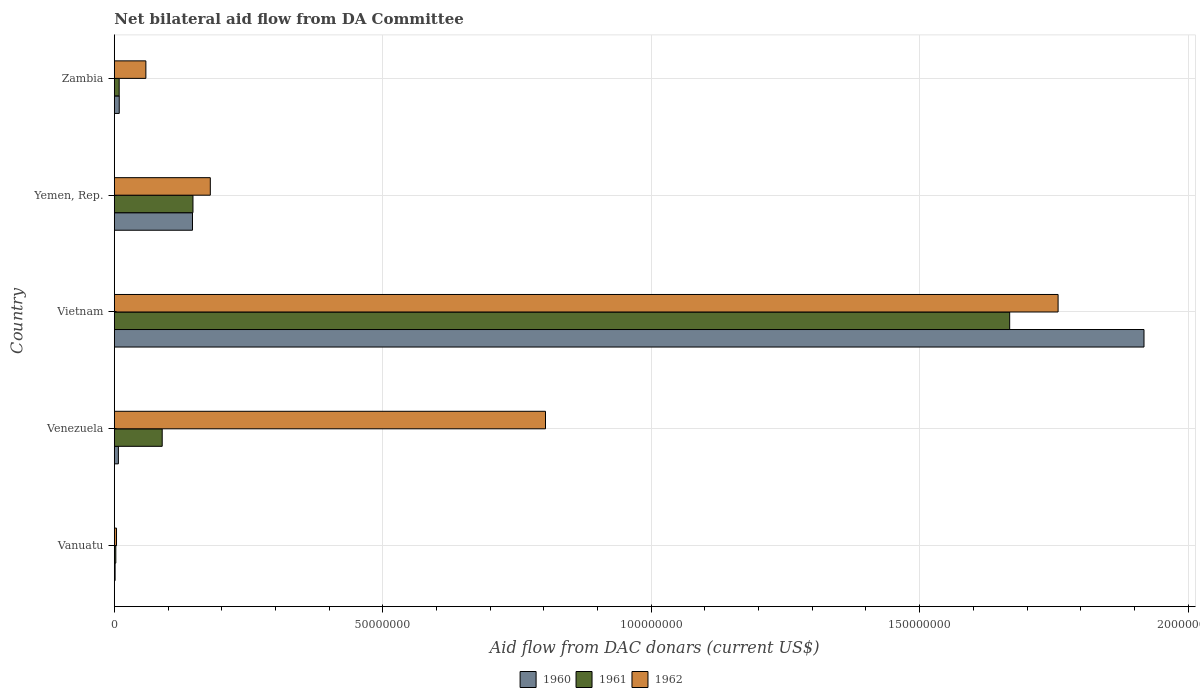How many different coloured bars are there?
Offer a terse response. 3. How many groups of bars are there?
Offer a very short reply. 5. Are the number of bars per tick equal to the number of legend labels?
Your answer should be very brief. Yes. What is the label of the 1st group of bars from the top?
Ensure brevity in your answer.  Zambia. What is the aid flow in in 1960 in Yemen, Rep.?
Your answer should be very brief. 1.46e+07. Across all countries, what is the maximum aid flow in in 1962?
Provide a succinct answer. 1.76e+08. In which country was the aid flow in in 1962 maximum?
Your answer should be very brief. Vietnam. In which country was the aid flow in in 1962 minimum?
Offer a terse response. Vanuatu. What is the total aid flow in in 1961 in the graph?
Offer a very short reply. 1.92e+08. What is the difference between the aid flow in in 1960 in Venezuela and that in Yemen, Rep.?
Provide a short and direct response. -1.38e+07. What is the average aid flow in in 1960 per country?
Ensure brevity in your answer.  4.16e+07. What is the difference between the aid flow in in 1960 and aid flow in in 1961 in Vietnam?
Offer a terse response. 2.50e+07. In how many countries, is the aid flow in in 1961 greater than 40000000 US$?
Your answer should be compact. 1. What is the ratio of the aid flow in in 1961 in Vietnam to that in Zambia?
Your answer should be very brief. 183.25. Is the aid flow in in 1960 in Vanuatu less than that in Zambia?
Your answer should be very brief. Yes. Is the difference between the aid flow in in 1960 in Vietnam and Yemen, Rep. greater than the difference between the aid flow in in 1961 in Vietnam and Yemen, Rep.?
Your answer should be very brief. Yes. What is the difference between the highest and the second highest aid flow in in 1960?
Give a very brief answer. 1.77e+08. What is the difference between the highest and the lowest aid flow in in 1960?
Your answer should be compact. 1.92e+08. Is the sum of the aid flow in in 1961 in Vietnam and Zambia greater than the maximum aid flow in in 1960 across all countries?
Offer a terse response. No. What does the 2nd bar from the bottom in Vanuatu represents?
Your answer should be compact. 1961. How many bars are there?
Give a very brief answer. 15. Are all the bars in the graph horizontal?
Provide a succinct answer. Yes. How many countries are there in the graph?
Your answer should be compact. 5. Are the values on the major ticks of X-axis written in scientific E-notation?
Offer a very short reply. No. Does the graph contain any zero values?
Give a very brief answer. No. Does the graph contain grids?
Keep it short and to the point. Yes. Where does the legend appear in the graph?
Provide a short and direct response. Bottom center. What is the title of the graph?
Make the answer very short. Net bilateral aid flow from DA Committee. Does "2015" appear as one of the legend labels in the graph?
Give a very brief answer. No. What is the label or title of the X-axis?
Provide a succinct answer. Aid flow from DAC donars (current US$). What is the Aid flow from DAC donars (current US$) in 1960 in Vanuatu?
Keep it short and to the point. 1.50e+05. What is the Aid flow from DAC donars (current US$) of 1961 in Vanuatu?
Ensure brevity in your answer.  2.80e+05. What is the Aid flow from DAC donars (current US$) of 1962 in Vanuatu?
Your answer should be very brief. 4.10e+05. What is the Aid flow from DAC donars (current US$) in 1960 in Venezuela?
Your answer should be very brief. 7.60e+05. What is the Aid flow from DAC donars (current US$) in 1961 in Venezuela?
Your response must be concise. 8.92e+06. What is the Aid flow from DAC donars (current US$) of 1962 in Venezuela?
Offer a terse response. 8.03e+07. What is the Aid flow from DAC donars (current US$) in 1960 in Vietnam?
Your answer should be very brief. 1.92e+08. What is the Aid flow from DAC donars (current US$) in 1961 in Vietnam?
Your response must be concise. 1.67e+08. What is the Aid flow from DAC donars (current US$) of 1962 in Vietnam?
Offer a terse response. 1.76e+08. What is the Aid flow from DAC donars (current US$) of 1960 in Yemen, Rep.?
Keep it short and to the point. 1.46e+07. What is the Aid flow from DAC donars (current US$) in 1961 in Yemen, Rep.?
Ensure brevity in your answer.  1.46e+07. What is the Aid flow from DAC donars (current US$) of 1962 in Yemen, Rep.?
Make the answer very short. 1.79e+07. What is the Aid flow from DAC donars (current US$) in 1960 in Zambia?
Offer a very short reply. 9.20e+05. What is the Aid flow from DAC donars (current US$) of 1961 in Zambia?
Give a very brief answer. 9.10e+05. What is the Aid flow from DAC donars (current US$) in 1962 in Zambia?
Offer a very short reply. 5.88e+06. Across all countries, what is the maximum Aid flow from DAC donars (current US$) in 1960?
Give a very brief answer. 1.92e+08. Across all countries, what is the maximum Aid flow from DAC donars (current US$) in 1961?
Your answer should be compact. 1.67e+08. Across all countries, what is the maximum Aid flow from DAC donars (current US$) in 1962?
Keep it short and to the point. 1.76e+08. Across all countries, what is the minimum Aid flow from DAC donars (current US$) in 1961?
Give a very brief answer. 2.80e+05. Across all countries, what is the minimum Aid flow from DAC donars (current US$) in 1962?
Your response must be concise. 4.10e+05. What is the total Aid flow from DAC donars (current US$) of 1960 in the graph?
Your answer should be very brief. 2.08e+08. What is the total Aid flow from DAC donars (current US$) in 1961 in the graph?
Ensure brevity in your answer.  1.92e+08. What is the total Aid flow from DAC donars (current US$) of 1962 in the graph?
Keep it short and to the point. 2.80e+08. What is the difference between the Aid flow from DAC donars (current US$) in 1960 in Vanuatu and that in Venezuela?
Offer a very short reply. -6.10e+05. What is the difference between the Aid flow from DAC donars (current US$) of 1961 in Vanuatu and that in Venezuela?
Your answer should be compact. -8.64e+06. What is the difference between the Aid flow from DAC donars (current US$) of 1962 in Vanuatu and that in Venezuela?
Provide a short and direct response. -7.99e+07. What is the difference between the Aid flow from DAC donars (current US$) in 1960 in Vanuatu and that in Vietnam?
Provide a succinct answer. -1.92e+08. What is the difference between the Aid flow from DAC donars (current US$) of 1961 in Vanuatu and that in Vietnam?
Offer a terse response. -1.66e+08. What is the difference between the Aid flow from DAC donars (current US$) in 1962 in Vanuatu and that in Vietnam?
Provide a succinct answer. -1.75e+08. What is the difference between the Aid flow from DAC donars (current US$) in 1960 in Vanuatu and that in Yemen, Rep.?
Ensure brevity in your answer.  -1.44e+07. What is the difference between the Aid flow from DAC donars (current US$) in 1961 in Vanuatu and that in Yemen, Rep.?
Give a very brief answer. -1.44e+07. What is the difference between the Aid flow from DAC donars (current US$) of 1962 in Vanuatu and that in Yemen, Rep.?
Offer a terse response. -1.75e+07. What is the difference between the Aid flow from DAC donars (current US$) of 1960 in Vanuatu and that in Zambia?
Offer a very short reply. -7.70e+05. What is the difference between the Aid flow from DAC donars (current US$) of 1961 in Vanuatu and that in Zambia?
Make the answer very short. -6.30e+05. What is the difference between the Aid flow from DAC donars (current US$) of 1962 in Vanuatu and that in Zambia?
Provide a succinct answer. -5.47e+06. What is the difference between the Aid flow from DAC donars (current US$) in 1960 in Venezuela and that in Vietnam?
Provide a short and direct response. -1.91e+08. What is the difference between the Aid flow from DAC donars (current US$) of 1961 in Venezuela and that in Vietnam?
Provide a succinct answer. -1.58e+08. What is the difference between the Aid flow from DAC donars (current US$) of 1962 in Venezuela and that in Vietnam?
Give a very brief answer. -9.55e+07. What is the difference between the Aid flow from DAC donars (current US$) of 1960 in Venezuela and that in Yemen, Rep.?
Provide a succinct answer. -1.38e+07. What is the difference between the Aid flow from DAC donars (current US$) of 1961 in Venezuela and that in Yemen, Rep.?
Offer a terse response. -5.73e+06. What is the difference between the Aid flow from DAC donars (current US$) of 1962 in Venezuela and that in Yemen, Rep.?
Provide a short and direct response. 6.24e+07. What is the difference between the Aid flow from DAC donars (current US$) of 1960 in Venezuela and that in Zambia?
Your answer should be very brief. -1.60e+05. What is the difference between the Aid flow from DAC donars (current US$) of 1961 in Venezuela and that in Zambia?
Ensure brevity in your answer.  8.01e+06. What is the difference between the Aid flow from DAC donars (current US$) in 1962 in Venezuela and that in Zambia?
Give a very brief answer. 7.44e+07. What is the difference between the Aid flow from DAC donars (current US$) in 1960 in Vietnam and that in Yemen, Rep.?
Offer a very short reply. 1.77e+08. What is the difference between the Aid flow from DAC donars (current US$) of 1961 in Vietnam and that in Yemen, Rep.?
Your response must be concise. 1.52e+08. What is the difference between the Aid flow from DAC donars (current US$) of 1962 in Vietnam and that in Yemen, Rep.?
Offer a very short reply. 1.58e+08. What is the difference between the Aid flow from DAC donars (current US$) of 1960 in Vietnam and that in Zambia?
Give a very brief answer. 1.91e+08. What is the difference between the Aid flow from DAC donars (current US$) of 1961 in Vietnam and that in Zambia?
Provide a short and direct response. 1.66e+08. What is the difference between the Aid flow from DAC donars (current US$) of 1962 in Vietnam and that in Zambia?
Your answer should be compact. 1.70e+08. What is the difference between the Aid flow from DAC donars (current US$) of 1960 in Yemen, Rep. and that in Zambia?
Ensure brevity in your answer.  1.36e+07. What is the difference between the Aid flow from DAC donars (current US$) in 1961 in Yemen, Rep. and that in Zambia?
Make the answer very short. 1.37e+07. What is the difference between the Aid flow from DAC donars (current US$) of 1962 in Yemen, Rep. and that in Zambia?
Offer a terse response. 1.20e+07. What is the difference between the Aid flow from DAC donars (current US$) in 1960 in Vanuatu and the Aid flow from DAC donars (current US$) in 1961 in Venezuela?
Your response must be concise. -8.77e+06. What is the difference between the Aid flow from DAC donars (current US$) in 1960 in Vanuatu and the Aid flow from DAC donars (current US$) in 1962 in Venezuela?
Provide a short and direct response. -8.02e+07. What is the difference between the Aid flow from DAC donars (current US$) in 1961 in Vanuatu and the Aid flow from DAC donars (current US$) in 1962 in Venezuela?
Offer a very short reply. -8.00e+07. What is the difference between the Aid flow from DAC donars (current US$) of 1960 in Vanuatu and the Aid flow from DAC donars (current US$) of 1961 in Vietnam?
Make the answer very short. -1.67e+08. What is the difference between the Aid flow from DAC donars (current US$) in 1960 in Vanuatu and the Aid flow from DAC donars (current US$) in 1962 in Vietnam?
Offer a terse response. -1.76e+08. What is the difference between the Aid flow from DAC donars (current US$) in 1961 in Vanuatu and the Aid flow from DAC donars (current US$) in 1962 in Vietnam?
Ensure brevity in your answer.  -1.76e+08. What is the difference between the Aid flow from DAC donars (current US$) of 1960 in Vanuatu and the Aid flow from DAC donars (current US$) of 1961 in Yemen, Rep.?
Provide a short and direct response. -1.45e+07. What is the difference between the Aid flow from DAC donars (current US$) of 1960 in Vanuatu and the Aid flow from DAC donars (current US$) of 1962 in Yemen, Rep.?
Offer a very short reply. -1.77e+07. What is the difference between the Aid flow from DAC donars (current US$) in 1961 in Vanuatu and the Aid flow from DAC donars (current US$) in 1962 in Yemen, Rep.?
Ensure brevity in your answer.  -1.76e+07. What is the difference between the Aid flow from DAC donars (current US$) of 1960 in Vanuatu and the Aid flow from DAC donars (current US$) of 1961 in Zambia?
Ensure brevity in your answer.  -7.60e+05. What is the difference between the Aid flow from DAC donars (current US$) of 1960 in Vanuatu and the Aid flow from DAC donars (current US$) of 1962 in Zambia?
Give a very brief answer. -5.73e+06. What is the difference between the Aid flow from DAC donars (current US$) of 1961 in Vanuatu and the Aid flow from DAC donars (current US$) of 1962 in Zambia?
Your answer should be very brief. -5.60e+06. What is the difference between the Aid flow from DAC donars (current US$) of 1960 in Venezuela and the Aid flow from DAC donars (current US$) of 1961 in Vietnam?
Offer a very short reply. -1.66e+08. What is the difference between the Aid flow from DAC donars (current US$) of 1960 in Venezuela and the Aid flow from DAC donars (current US$) of 1962 in Vietnam?
Provide a short and direct response. -1.75e+08. What is the difference between the Aid flow from DAC donars (current US$) in 1961 in Venezuela and the Aid flow from DAC donars (current US$) in 1962 in Vietnam?
Make the answer very short. -1.67e+08. What is the difference between the Aid flow from DAC donars (current US$) in 1960 in Venezuela and the Aid flow from DAC donars (current US$) in 1961 in Yemen, Rep.?
Your answer should be very brief. -1.39e+07. What is the difference between the Aid flow from DAC donars (current US$) in 1960 in Venezuela and the Aid flow from DAC donars (current US$) in 1962 in Yemen, Rep.?
Keep it short and to the point. -1.71e+07. What is the difference between the Aid flow from DAC donars (current US$) in 1961 in Venezuela and the Aid flow from DAC donars (current US$) in 1962 in Yemen, Rep.?
Your answer should be very brief. -8.96e+06. What is the difference between the Aid flow from DAC donars (current US$) in 1960 in Venezuela and the Aid flow from DAC donars (current US$) in 1962 in Zambia?
Your answer should be compact. -5.12e+06. What is the difference between the Aid flow from DAC donars (current US$) in 1961 in Venezuela and the Aid flow from DAC donars (current US$) in 1962 in Zambia?
Offer a very short reply. 3.04e+06. What is the difference between the Aid flow from DAC donars (current US$) of 1960 in Vietnam and the Aid flow from DAC donars (current US$) of 1961 in Yemen, Rep.?
Ensure brevity in your answer.  1.77e+08. What is the difference between the Aid flow from DAC donars (current US$) in 1960 in Vietnam and the Aid flow from DAC donars (current US$) in 1962 in Yemen, Rep.?
Give a very brief answer. 1.74e+08. What is the difference between the Aid flow from DAC donars (current US$) of 1961 in Vietnam and the Aid flow from DAC donars (current US$) of 1962 in Yemen, Rep.?
Your answer should be compact. 1.49e+08. What is the difference between the Aid flow from DAC donars (current US$) of 1960 in Vietnam and the Aid flow from DAC donars (current US$) of 1961 in Zambia?
Give a very brief answer. 1.91e+08. What is the difference between the Aid flow from DAC donars (current US$) of 1960 in Vietnam and the Aid flow from DAC donars (current US$) of 1962 in Zambia?
Make the answer very short. 1.86e+08. What is the difference between the Aid flow from DAC donars (current US$) in 1961 in Vietnam and the Aid flow from DAC donars (current US$) in 1962 in Zambia?
Offer a very short reply. 1.61e+08. What is the difference between the Aid flow from DAC donars (current US$) in 1960 in Yemen, Rep. and the Aid flow from DAC donars (current US$) in 1961 in Zambia?
Your answer should be compact. 1.36e+07. What is the difference between the Aid flow from DAC donars (current US$) in 1960 in Yemen, Rep. and the Aid flow from DAC donars (current US$) in 1962 in Zambia?
Ensure brevity in your answer.  8.68e+06. What is the difference between the Aid flow from DAC donars (current US$) of 1961 in Yemen, Rep. and the Aid flow from DAC donars (current US$) of 1962 in Zambia?
Provide a succinct answer. 8.77e+06. What is the average Aid flow from DAC donars (current US$) of 1960 per country?
Provide a short and direct response. 4.16e+07. What is the average Aid flow from DAC donars (current US$) in 1961 per country?
Give a very brief answer. 3.83e+07. What is the average Aid flow from DAC donars (current US$) of 1962 per country?
Provide a succinct answer. 5.61e+07. What is the difference between the Aid flow from DAC donars (current US$) of 1960 and Aid flow from DAC donars (current US$) of 1962 in Vanuatu?
Provide a short and direct response. -2.60e+05. What is the difference between the Aid flow from DAC donars (current US$) in 1961 and Aid flow from DAC donars (current US$) in 1962 in Vanuatu?
Provide a short and direct response. -1.30e+05. What is the difference between the Aid flow from DAC donars (current US$) of 1960 and Aid flow from DAC donars (current US$) of 1961 in Venezuela?
Make the answer very short. -8.16e+06. What is the difference between the Aid flow from DAC donars (current US$) of 1960 and Aid flow from DAC donars (current US$) of 1962 in Venezuela?
Provide a succinct answer. -7.96e+07. What is the difference between the Aid flow from DAC donars (current US$) of 1961 and Aid flow from DAC donars (current US$) of 1962 in Venezuela?
Make the answer very short. -7.14e+07. What is the difference between the Aid flow from DAC donars (current US$) in 1960 and Aid flow from DAC donars (current US$) in 1961 in Vietnam?
Give a very brief answer. 2.50e+07. What is the difference between the Aid flow from DAC donars (current US$) in 1960 and Aid flow from DAC donars (current US$) in 1962 in Vietnam?
Provide a succinct answer. 1.60e+07. What is the difference between the Aid flow from DAC donars (current US$) in 1961 and Aid flow from DAC donars (current US$) in 1962 in Vietnam?
Offer a very short reply. -9.02e+06. What is the difference between the Aid flow from DAC donars (current US$) of 1960 and Aid flow from DAC donars (current US$) of 1962 in Yemen, Rep.?
Make the answer very short. -3.32e+06. What is the difference between the Aid flow from DAC donars (current US$) of 1961 and Aid flow from DAC donars (current US$) of 1962 in Yemen, Rep.?
Provide a short and direct response. -3.23e+06. What is the difference between the Aid flow from DAC donars (current US$) of 1960 and Aid flow from DAC donars (current US$) of 1962 in Zambia?
Provide a short and direct response. -4.96e+06. What is the difference between the Aid flow from DAC donars (current US$) in 1961 and Aid flow from DAC donars (current US$) in 1962 in Zambia?
Your response must be concise. -4.97e+06. What is the ratio of the Aid flow from DAC donars (current US$) in 1960 in Vanuatu to that in Venezuela?
Provide a succinct answer. 0.2. What is the ratio of the Aid flow from DAC donars (current US$) in 1961 in Vanuatu to that in Venezuela?
Your response must be concise. 0.03. What is the ratio of the Aid flow from DAC donars (current US$) in 1962 in Vanuatu to that in Venezuela?
Keep it short and to the point. 0.01. What is the ratio of the Aid flow from DAC donars (current US$) in 1960 in Vanuatu to that in Vietnam?
Provide a short and direct response. 0. What is the ratio of the Aid flow from DAC donars (current US$) of 1961 in Vanuatu to that in Vietnam?
Give a very brief answer. 0. What is the ratio of the Aid flow from DAC donars (current US$) in 1962 in Vanuatu to that in Vietnam?
Provide a succinct answer. 0. What is the ratio of the Aid flow from DAC donars (current US$) in 1960 in Vanuatu to that in Yemen, Rep.?
Your response must be concise. 0.01. What is the ratio of the Aid flow from DAC donars (current US$) of 1961 in Vanuatu to that in Yemen, Rep.?
Provide a succinct answer. 0.02. What is the ratio of the Aid flow from DAC donars (current US$) in 1962 in Vanuatu to that in Yemen, Rep.?
Your answer should be very brief. 0.02. What is the ratio of the Aid flow from DAC donars (current US$) in 1960 in Vanuatu to that in Zambia?
Your answer should be compact. 0.16. What is the ratio of the Aid flow from DAC donars (current US$) in 1961 in Vanuatu to that in Zambia?
Give a very brief answer. 0.31. What is the ratio of the Aid flow from DAC donars (current US$) in 1962 in Vanuatu to that in Zambia?
Make the answer very short. 0.07. What is the ratio of the Aid flow from DAC donars (current US$) of 1960 in Venezuela to that in Vietnam?
Keep it short and to the point. 0. What is the ratio of the Aid flow from DAC donars (current US$) in 1961 in Venezuela to that in Vietnam?
Offer a terse response. 0.05. What is the ratio of the Aid flow from DAC donars (current US$) of 1962 in Venezuela to that in Vietnam?
Provide a short and direct response. 0.46. What is the ratio of the Aid flow from DAC donars (current US$) in 1960 in Venezuela to that in Yemen, Rep.?
Provide a succinct answer. 0.05. What is the ratio of the Aid flow from DAC donars (current US$) in 1961 in Venezuela to that in Yemen, Rep.?
Offer a very short reply. 0.61. What is the ratio of the Aid flow from DAC donars (current US$) in 1962 in Venezuela to that in Yemen, Rep.?
Give a very brief answer. 4.49. What is the ratio of the Aid flow from DAC donars (current US$) in 1960 in Venezuela to that in Zambia?
Keep it short and to the point. 0.83. What is the ratio of the Aid flow from DAC donars (current US$) of 1961 in Venezuela to that in Zambia?
Give a very brief answer. 9.8. What is the ratio of the Aid flow from DAC donars (current US$) in 1962 in Venezuela to that in Zambia?
Make the answer very short. 13.66. What is the ratio of the Aid flow from DAC donars (current US$) of 1960 in Vietnam to that in Yemen, Rep.?
Provide a succinct answer. 13.17. What is the ratio of the Aid flow from DAC donars (current US$) in 1961 in Vietnam to that in Yemen, Rep.?
Make the answer very short. 11.38. What is the ratio of the Aid flow from DAC donars (current US$) in 1962 in Vietnam to that in Yemen, Rep.?
Offer a terse response. 9.83. What is the ratio of the Aid flow from DAC donars (current US$) of 1960 in Vietnam to that in Zambia?
Ensure brevity in your answer.  208.46. What is the ratio of the Aid flow from DAC donars (current US$) in 1961 in Vietnam to that in Zambia?
Keep it short and to the point. 183.25. What is the ratio of the Aid flow from DAC donars (current US$) of 1962 in Vietnam to that in Zambia?
Offer a very short reply. 29.89. What is the ratio of the Aid flow from DAC donars (current US$) of 1960 in Yemen, Rep. to that in Zambia?
Make the answer very short. 15.83. What is the ratio of the Aid flow from DAC donars (current US$) in 1961 in Yemen, Rep. to that in Zambia?
Provide a short and direct response. 16.1. What is the ratio of the Aid flow from DAC donars (current US$) in 1962 in Yemen, Rep. to that in Zambia?
Your answer should be compact. 3.04. What is the difference between the highest and the second highest Aid flow from DAC donars (current US$) of 1960?
Provide a short and direct response. 1.77e+08. What is the difference between the highest and the second highest Aid flow from DAC donars (current US$) in 1961?
Your answer should be compact. 1.52e+08. What is the difference between the highest and the second highest Aid flow from DAC donars (current US$) of 1962?
Offer a terse response. 9.55e+07. What is the difference between the highest and the lowest Aid flow from DAC donars (current US$) of 1960?
Make the answer very short. 1.92e+08. What is the difference between the highest and the lowest Aid flow from DAC donars (current US$) in 1961?
Provide a succinct answer. 1.66e+08. What is the difference between the highest and the lowest Aid flow from DAC donars (current US$) of 1962?
Your answer should be very brief. 1.75e+08. 